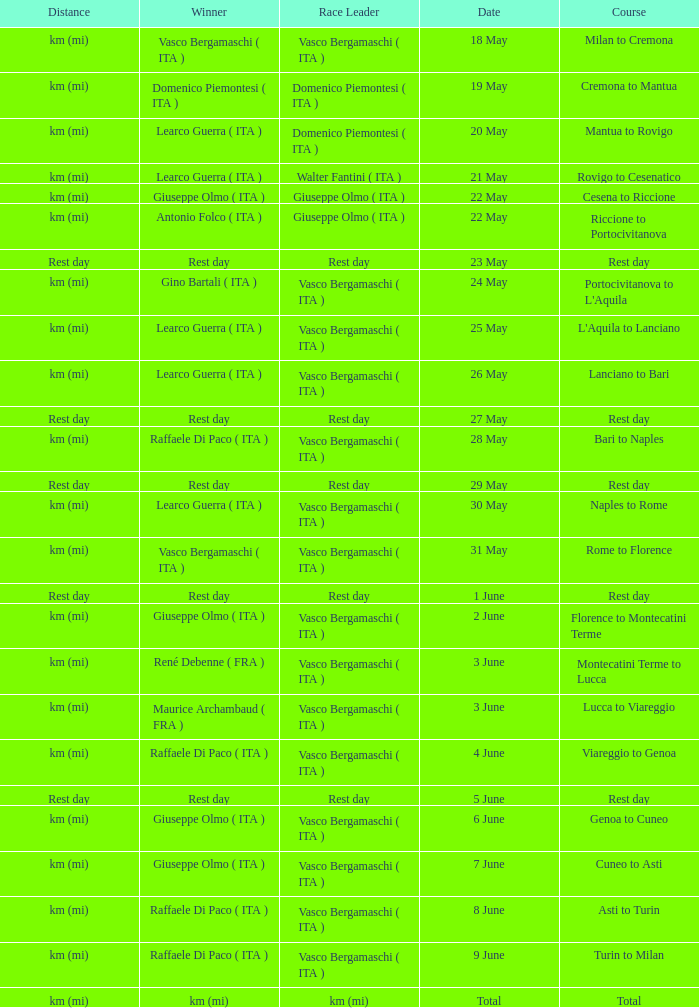Who won on 28 May? Raffaele Di Paco ( ITA ). Could you parse the entire table as a dict? {'header': ['Distance', 'Winner', 'Race Leader', 'Date', 'Course'], 'rows': [['km (mi)', 'Vasco Bergamaschi ( ITA )', 'Vasco Bergamaschi ( ITA )', '18 May', 'Milan to Cremona'], ['km (mi)', 'Domenico Piemontesi ( ITA )', 'Domenico Piemontesi ( ITA )', '19 May', 'Cremona to Mantua'], ['km (mi)', 'Learco Guerra ( ITA )', 'Domenico Piemontesi ( ITA )', '20 May', 'Mantua to Rovigo'], ['km (mi)', 'Learco Guerra ( ITA )', 'Walter Fantini ( ITA )', '21 May', 'Rovigo to Cesenatico'], ['km (mi)', 'Giuseppe Olmo ( ITA )', 'Giuseppe Olmo ( ITA )', '22 May', 'Cesena to Riccione'], ['km (mi)', 'Antonio Folco ( ITA )', 'Giuseppe Olmo ( ITA )', '22 May', 'Riccione to Portocivitanova'], ['Rest day', 'Rest day', 'Rest day', '23 May', 'Rest day'], ['km (mi)', 'Gino Bartali ( ITA )', 'Vasco Bergamaschi ( ITA )', '24 May', "Portocivitanova to L'Aquila"], ['km (mi)', 'Learco Guerra ( ITA )', 'Vasco Bergamaschi ( ITA )', '25 May', "L'Aquila to Lanciano"], ['km (mi)', 'Learco Guerra ( ITA )', 'Vasco Bergamaschi ( ITA )', '26 May', 'Lanciano to Bari'], ['Rest day', 'Rest day', 'Rest day', '27 May', 'Rest day'], ['km (mi)', 'Raffaele Di Paco ( ITA )', 'Vasco Bergamaschi ( ITA )', '28 May', 'Bari to Naples'], ['Rest day', 'Rest day', 'Rest day', '29 May', 'Rest day'], ['km (mi)', 'Learco Guerra ( ITA )', 'Vasco Bergamaschi ( ITA )', '30 May', 'Naples to Rome'], ['km (mi)', 'Vasco Bergamaschi ( ITA )', 'Vasco Bergamaschi ( ITA )', '31 May', 'Rome to Florence'], ['Rest day', 'Rest day', 'Rest day', '1 June', 'Rest day'], ['km (mi)', 'Giuseppe Olmo ( ITA )', 'Vasco Bergamaschi ( ITA )', '2 June', 'Florence to Montecatini Terme'], ['km (mi)', 'René Debenne ( FRA )', 'Vasco Bergamaschi ( ITA )', '3 June', 'Montecatini Terme to Lucca'], ['km (mi)', 'Maurice Archambaud ( FRA )', 'Vasco Bergamaschi ( ITA )', '3 June', 'Lucca to Viareggio'], ['km (mi)', 'Raffaele Di Paco ( ITA )', 'Vasco Bergamaschi ( ITA )', '4 June', 'Viareggio to Genoa'], ['Rest day', 'Rest day', 'Rest day', '5 June', 'Rest day'], ['km (mi)', 'Giuseppe Olmo ( ITA )', 'Vasco Bergamaschi ( ITA )', '6 June', 'Genoa to Cuneo'], ['km (mi)', 'Giuseppe Olmo ( ITA )', 'Vasco Bergamaschi ( ITA )', '7 June', 'Cuneo to Asti'], ['km (mi)', 'Raffaele Di Paco ( ITA )', 'Vasco Bergamaschi ( ITA )', '8 June', 'Asti to Turin'], ['km (mi)', 'Raffaele Di Paco ( ITA )', 'Vasco Bergamaschi ( ITA )', '9 June', 'Turin to Milan'], ['km (mi)', 'km (mi)', 'km (mi)', 'Total', 'Total']]} 